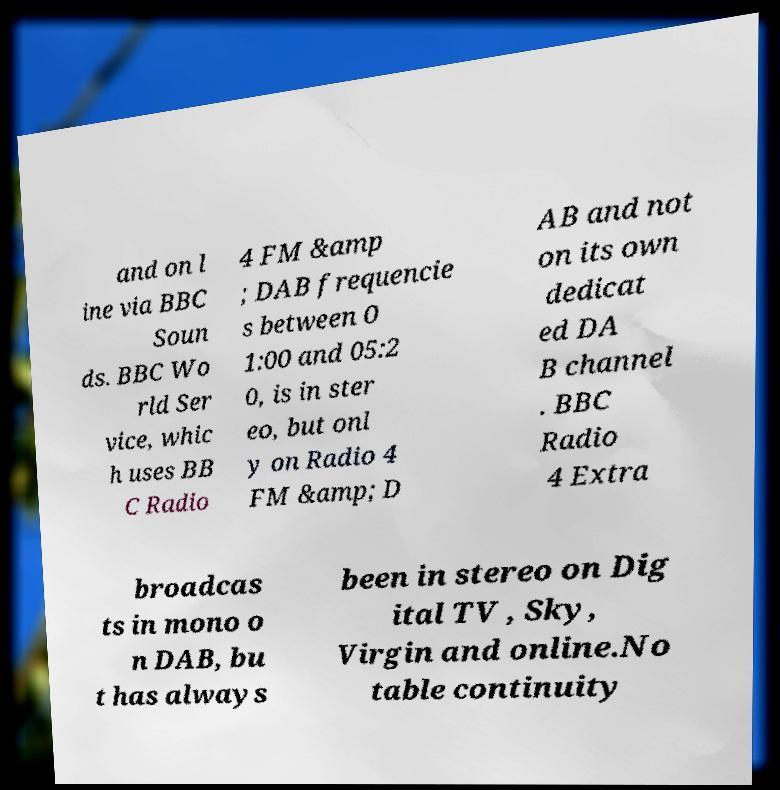I need the written content from this picture converted into text. Can you do that? and on l ine via BBC Soun ds. BBC Wo rld Ser vice, whic h uses BB C Radio 4 FM &amp ; DAB frequencie s between 0 1:00 and 05:2 0, is in ster eo, but onl y on Radio 4 FM &amp; D AB and not on its own dedicat ed DA B channel . BBC Radio 4 Extra broadcas ts in mono o n DAB, bu t has always been in stereo on Dig ital TV , Sky, Virgin and online.No table continuity 